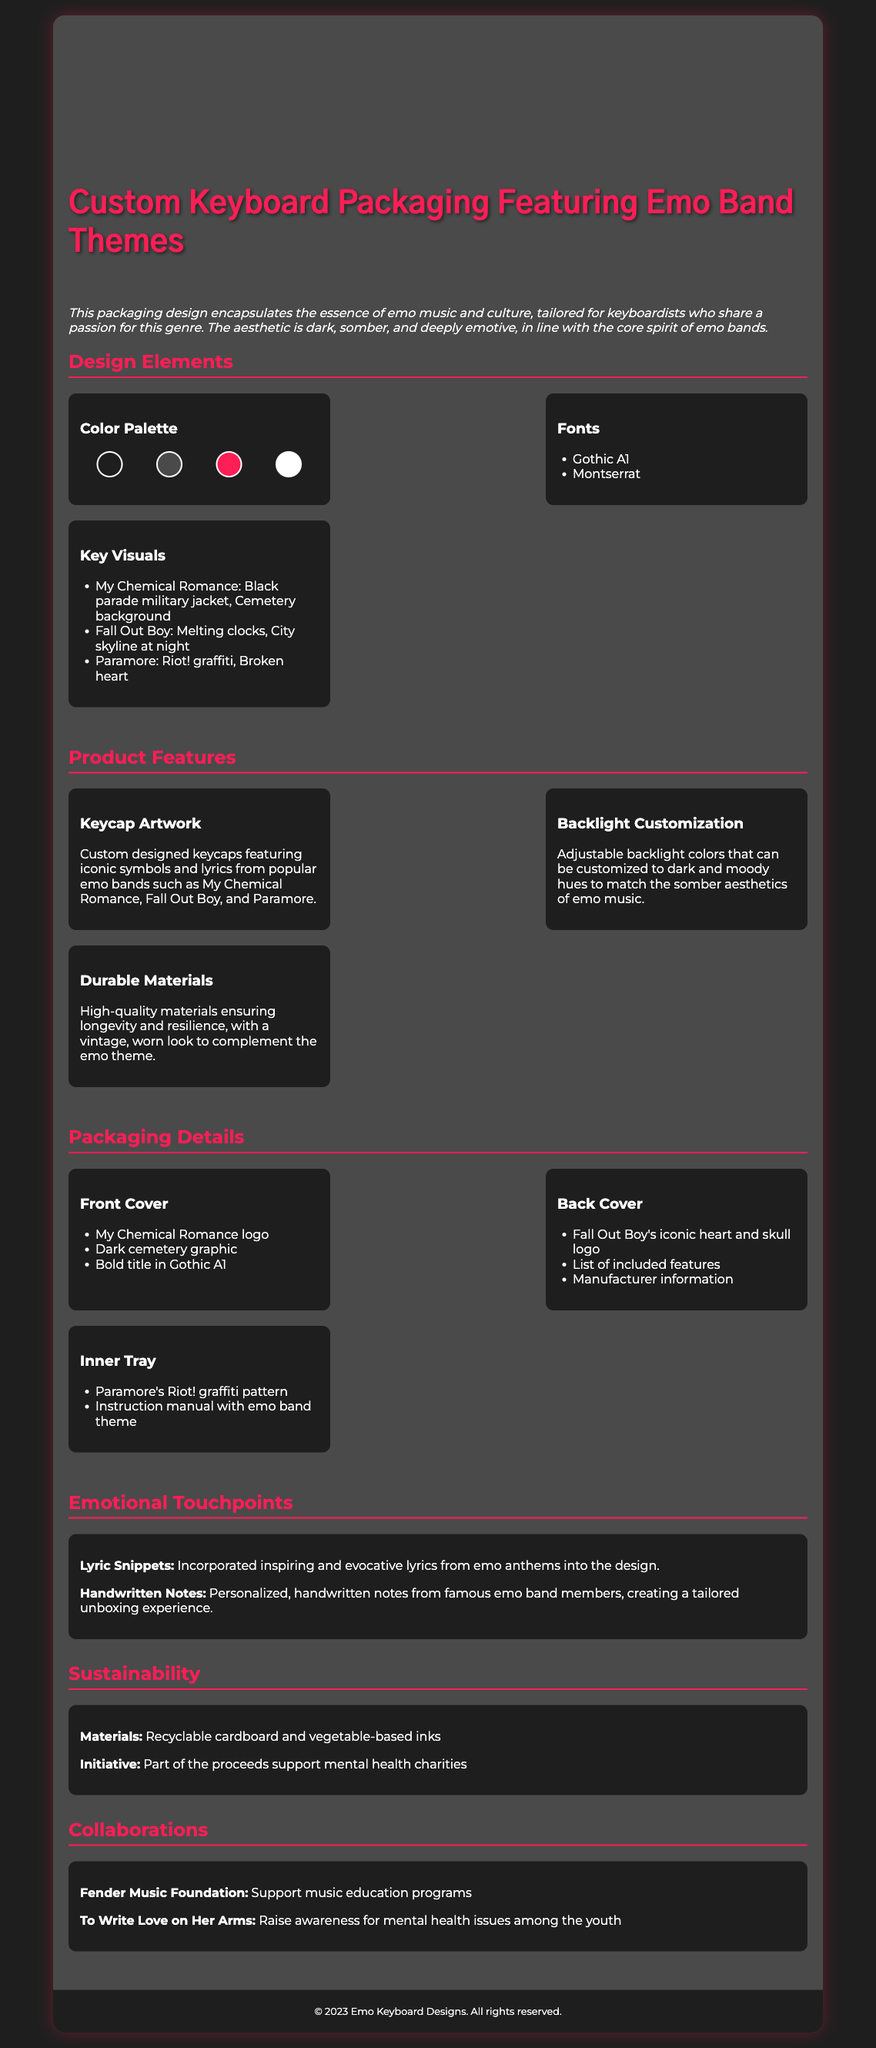What is the primary theme of the packaging? The primary theme of the packaging is based on emo music and culture, tailored for keyboardists.
Answer: emo music What colors are included in the color palette? The colors in the palette include dark colors and an accent color, relevant to emo aesthetics.
Answer: #1e1e1e, #4a4a4a, #ff1e56, #ffffff Which band is associated with the "Black parade military jacket"? The visual is associated with My Chemical Romance.
Answer: My Chemical Romance What kind of materials are used in the packaging? The packaging uses recyclable and eco-friendly materials.
Answer: recyclable cardboard What type of customization is available for the backlight? The backlight can be customized in various hues to match emo aesthetics.
Answer: Adjustable backlight Who do the handwritten notes in the packaging come from? The notes are from famous emo band members, enhancing the unboxing experience.
Answer: famous emo band members What charitable initiative is supported by part of the proceeds? The initiative supports mental health charities.
Answer: mental health charities What key visual refers to "melting clocks"? The visual refers to Fall Out Boy.
Answer: Fall Out Boy Which emotional touchpoint features inspiring lyrics? Lyric snippets are incorporated into the design.
Answer: Lyric snippets 